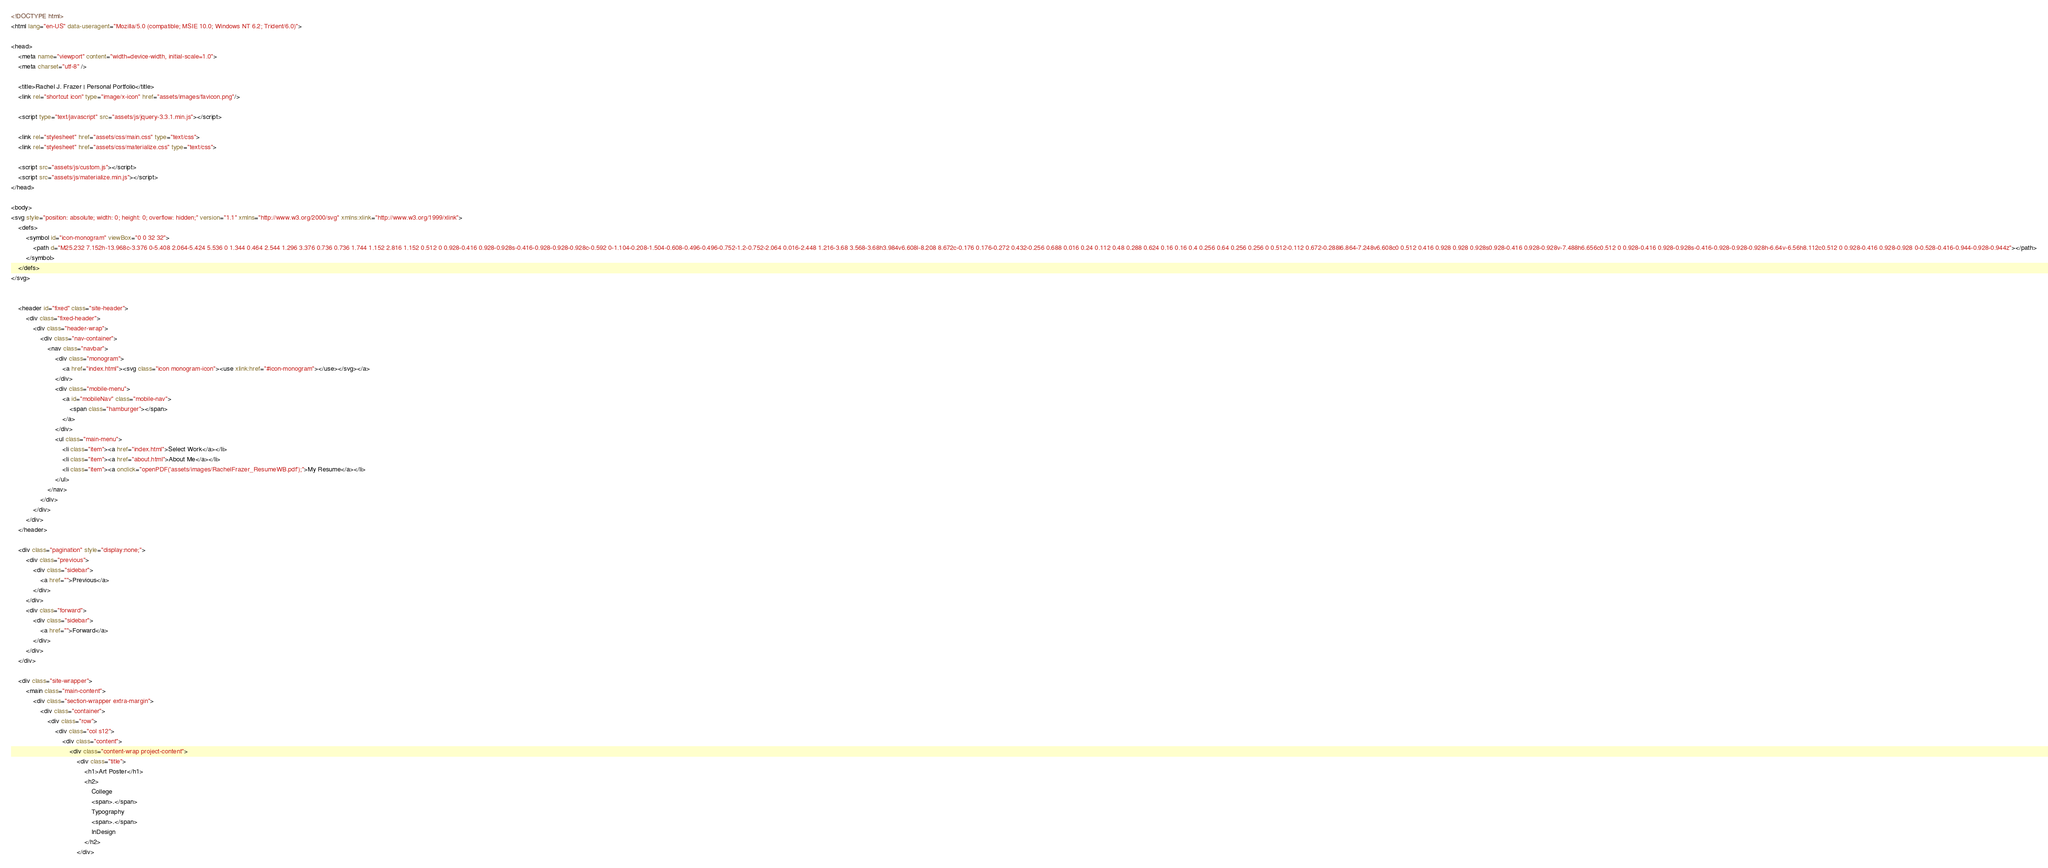Convert code to text. <code><loc_0><loc_0><loc_500><loc_500><_HTML_><!DOCTYPE html>
<html lang="en-US" data-useragent="Mozilla/5.0 (compatible; MSIE 10.0; Windows NT 6.2; Trident/6.0)">
    
<head>
    <meta name="viewport" content="width=device-width, initial-scale=1.0">
    <meta charset="utf-8" />
    
    <title>Rachel J. Frazer | Personal Portfolio</title>
    <link rel="shortcut icon" type="image/x-icon" href="assets/images/favicon.png"/>
    
    <script type="text/javascript" src="assets/js/jquery-3.3.1.min.js"></script>
    
    <link rel="stylesheet" href="assets/css/main.css" type="text/css">
    <link rel="stylesheet" href="assets/css/materialize.css" type="text/css">

    <script src="assets/js/custom.js"></script>
    <script src="assets/js/materialize.min.js"></script>
</head>

<body>
<svg style="position: absolute; width: 0; height: 0; overflow: hidden;" version="1.1" xmlns="http://www.w3.org/2000/svg" xmlns:xlink="http://www.w3.org/1999/xlink">
    <defs>    
        <symbol id="icon-monogram" viewBox="0 0 32 32">
            <path d="M25.232 7.152h-13.968c-3.376 0-5.408 2.064-5.424 5.536 0 1.344 0.464 2.544 1.296 3.376 0.736 0.736 1.744 1.152 2.816 1.152 0.512 0 0.928-0.416 0.928-0.928s-0.416-0.928-0.928-0.928c-0.592 0-1.104-0.208-1.504-0.608-0.496-0.496-0.752-1.2-0.752-2.064 0.016-2.448 1.216-3.68 3.568-3.68h3.984v6.608l-8.208 8.672c-0.176 0.176-0.272 0.432-0.256 0.688 0.016 0.24 0.112 0.48 0.288 0.624 0.16 0.16 0.4 0.256 0.64 0.256 0.256 0 0.512-0.112 0.672-0.288l6.864-7.248v6.608c0 0.512 0.416 0.928 0.928 0.928s0.928-0.416 0.928-0.928v-7.488h6.656c0.512 0 0.928-0.416 0.928-0.928s-0.416-0.928-0.928-0.928h-6.64v-6.56h8.112c0.512 0 0.928-0.416 0.928-0.928 0-0.528-0.416-0.944-0.928-0.944z"></path>
        </symbol>
    </defs>
</svg>
    

    <header id="fixed" class="site-header">
        <div class="fixed-header">
            <div class="header-wrap">
                <div class="nav-container">
                    <nav class="navbar">
                        <div class="monogram">
                            <a href="index.html"><svg class="icon monogram-icon"><use xlink:href="#icon-monogram"></use></svg></a>
                        </div>
                        <div class="mobile-menu">
                            <a id="mobileNav" class="mobile-nav">
                                <span class="hamburger"></span>
                            </a>
                        </div>
                        <ul class="main-menu">
                            <li class="item"><a href="index.html">Select Work</a></li>
                            <li class="item"><a href="about.html">About Me</a></li>
                            <li class="item"><a onclick="openPDF('assets/images/RachelFrazer_ResumeWB.pdf');">My Resume</a></li>
                        </ul>
                    </nav>
                </div>
            </div>
        </div>
    </header>

    <div class="pagination" style="display:none;">
        <div class="previous">
            <div class="sidebar">
                <a href="">Previous</a>
            </div>
        </div>
        <div class="forward">
            <div class="sidebar">
                <a href="">Forward</a>
            </div>
        </div>
    </div>
    
    <div class="site-wrapper">
        <main class="main-content">
            <div class="section-wrapper extra-margin">
                <div class="container">
                    <div class="row">
                        <div class="col s12">
                            <div class="content">
                                <div class="content-wrap project-content">
                                    <div class="title">
                                        <h1>Art Poster</h1>
                                        <h2>
                                            College
                                            <span>.</span>
                                            Typography
                                            <span>.</span>
                                            InDesign
                                        </h2>
                                    </div></code> 